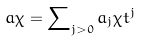Convert formula to latex. <formula><loc_0><loc_0><loc_500><loc_500>a \chi = \sum \nolimits _ { j > 0 } a _ { j } \chi t ^ { j }</formula> 